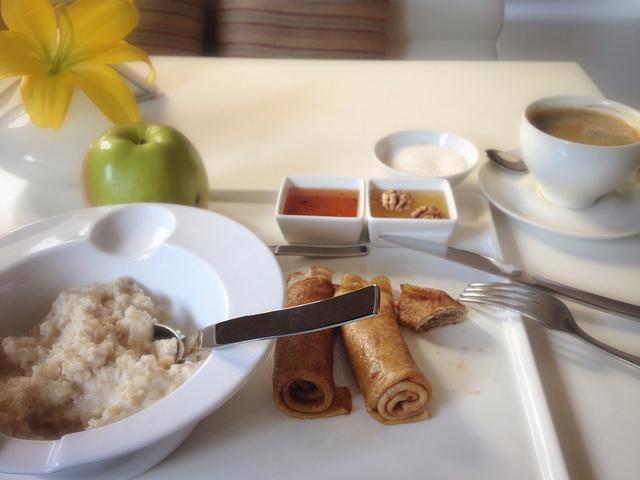How many bowls can you see?
Give a very brief answer. 5. How many dogs are wearing a chain collar?
Give a very brief answer. 0. 